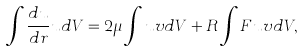<formula> <loc_0><loc_0><loc_500><loc_500>\int \frac { d u } { d r } u d V = 2 \mu \int u v d V + R \int F u v d V ,</formula> 